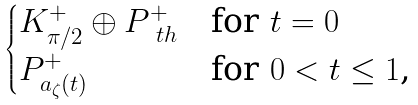<formula> <loc_0><loc_0><loc_500><loc_500>\begin{cases} K ^ { + } _ { \pi / 2 } \oplus P ^ { + } _ { \ t h } & \text {for   $t=0$} \\ P ^ { + } _ { a _ { \zeta } ( t ) } & \text {for $0<t\leq 1$,} \end{cases}</formula> 